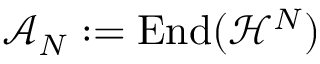<formula> <loc_0><loc_0><loc_500><loc_500>\mathcal { A } _ { N } \colon = E n d ( \mathcal { H } ^ { N } )</formula> 